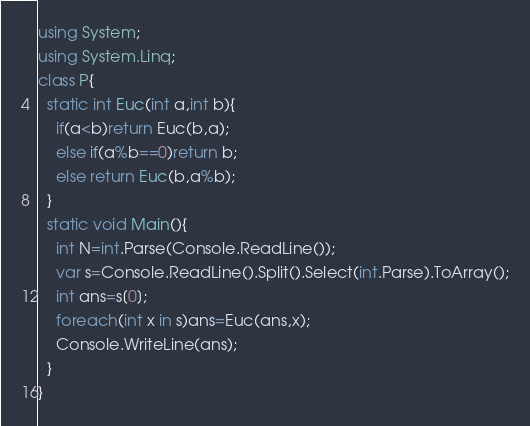<code> <loc_0><loc_0><loc_500><loc_500><_C#_>using System;
using System.Linq;
class P{
  static int Euc(int a,int b){
    if(a<b)return Euc(b,a);
    else if(a%b==0)return b;
    else return Euc(b,a%b);
  }
  static void Main(){
    int N=int.Parse(Console.ReadLine());
    var s=Console.ReadLine().Split().Select(int.Parse).ToArray();
    int ans=s[0];
    foreach(int x in s)ans=Euc(ans,x);
    Console.WriteLine(ans);
  }
}</code> 